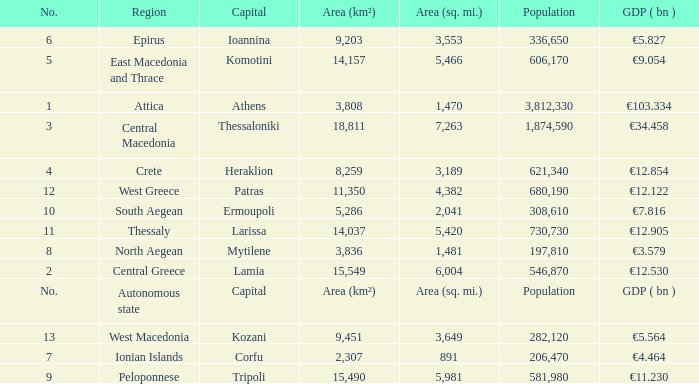What is the gdp ( bn ) where capital is capital? GDP ( bn ). 